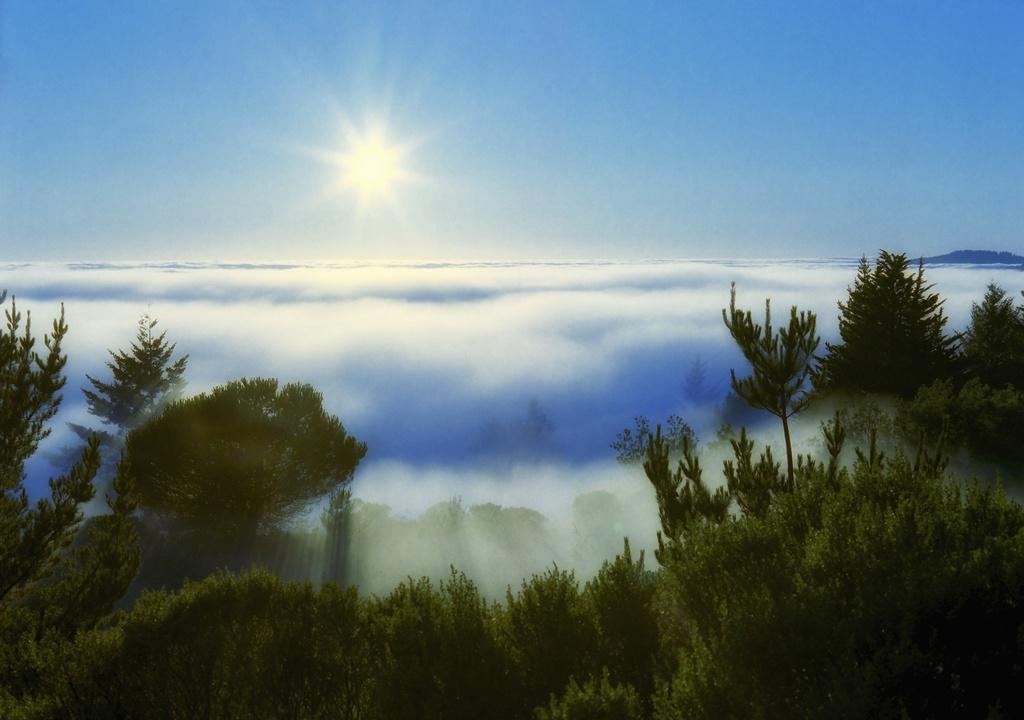In one or two sentences, can you explain what this image depicts? This is an edited image, in the image at the bottom there are some trees, in the middle there are some clouds, sun light and the sky visible at the top. 